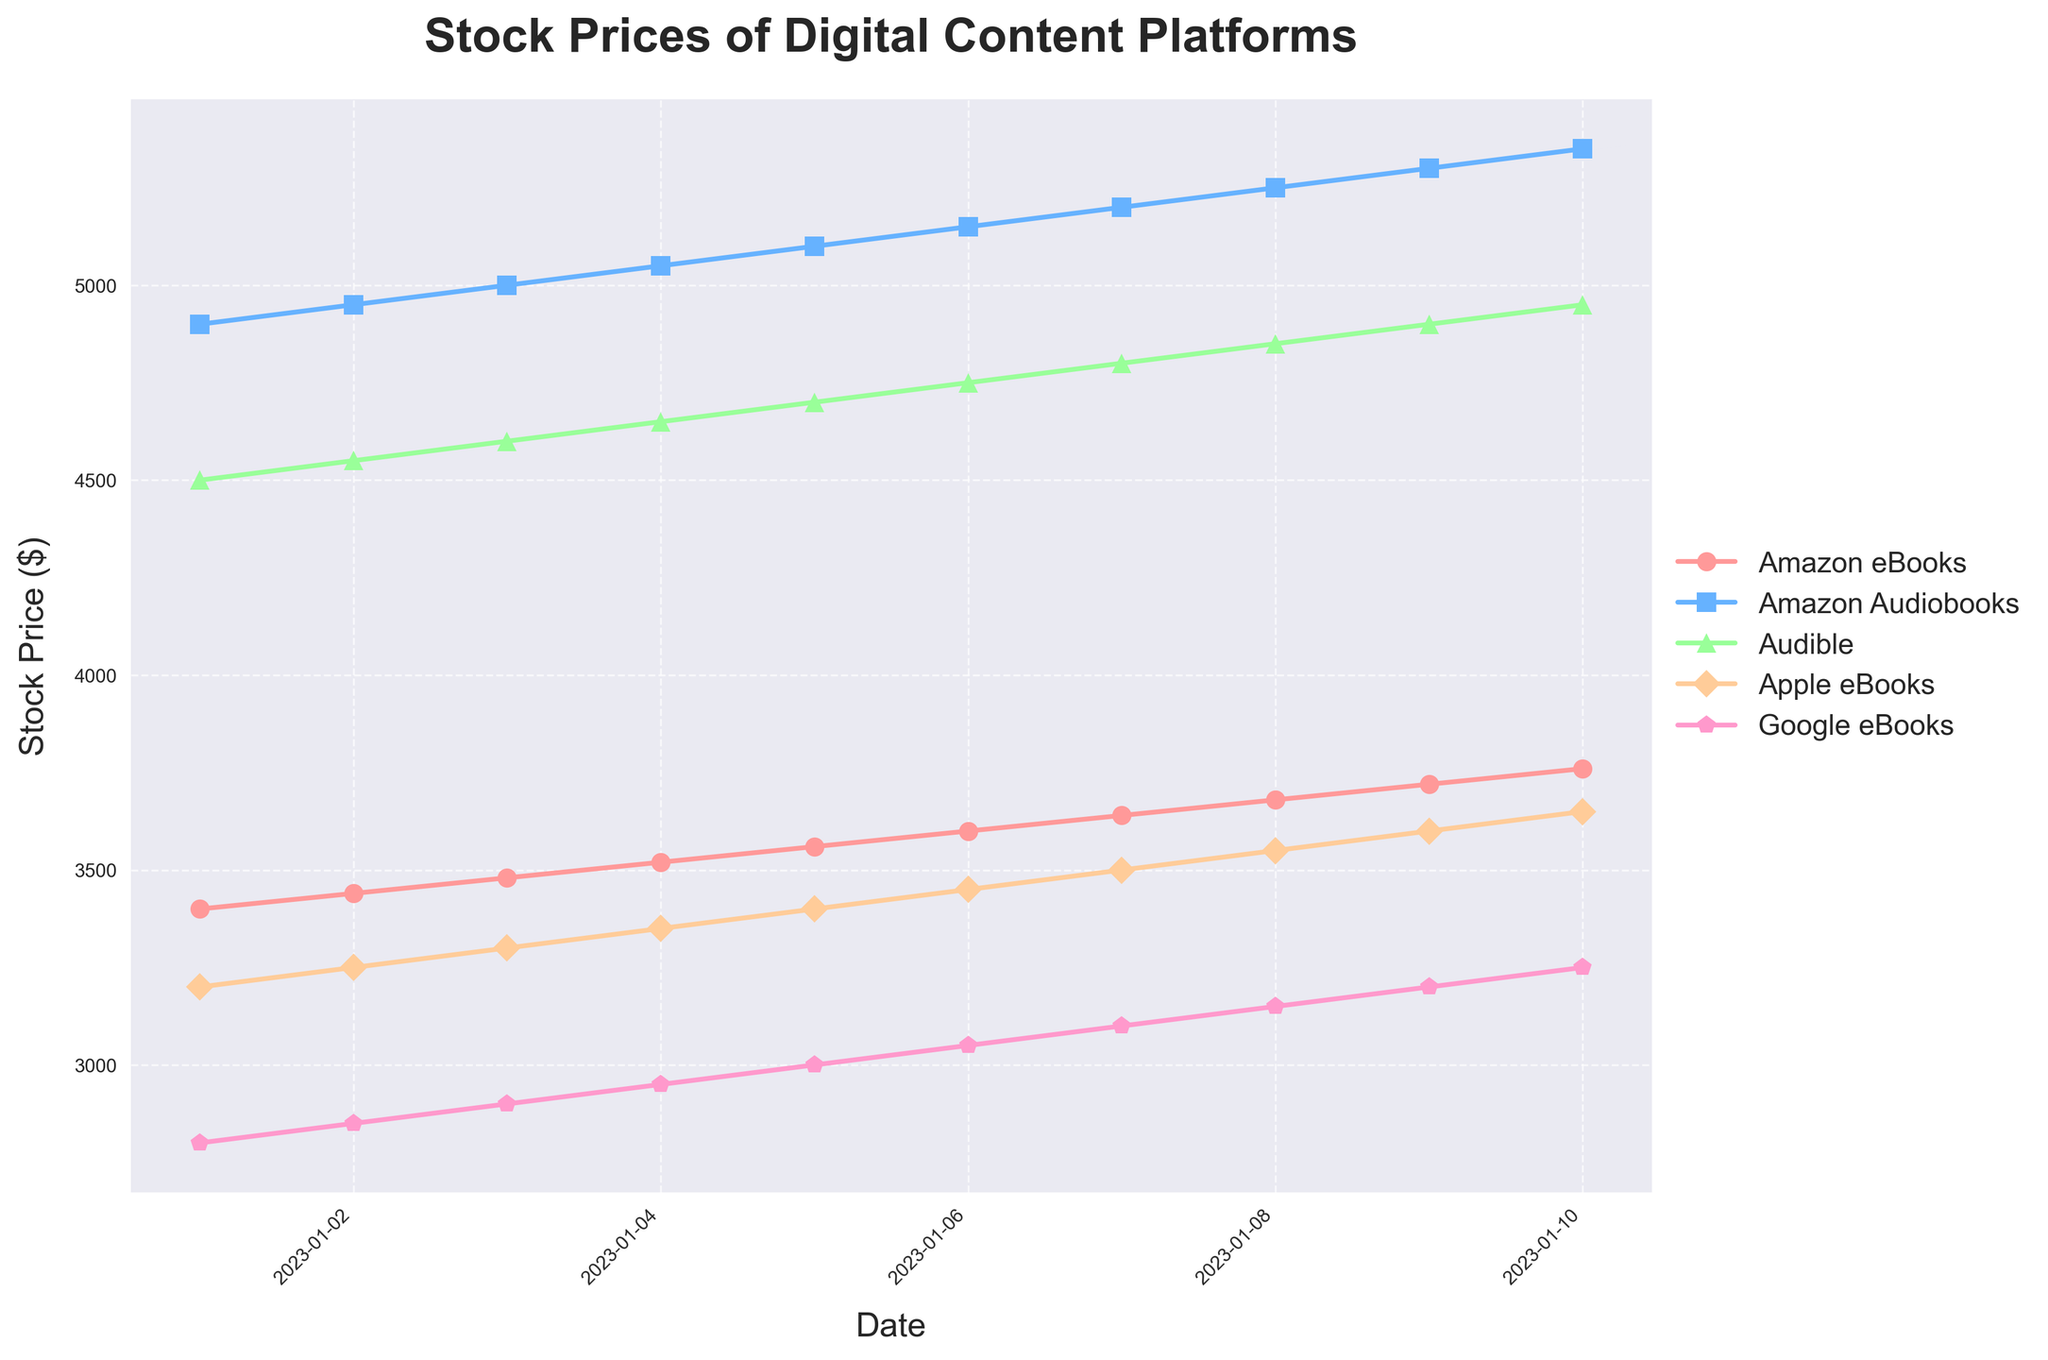What is the title of the plot? The title is the large, bold text at the top of the chart. It provides a concise description of what the chart is depicting.
Answer: Stock Prices of Digital Content Platforms How many companies' stock prices are plotted on the chart? By counting the number of distinct lines in the plot, each representing a different company.
Answer: 5 What is the color of the line representing Google eBooks? By looking at the legend on the right side of the plot and matching the company name to its corresponding line color.
Answer: Pink What is the stock price of Amazon Audiobooks on January 8, 2023? Locate the date January 8, 2023, on the x-axis and find the corresponding point on the line for Amazon Audiobooks.
Answer: 5250 Which company's stock price showed the highest increase from January 1 to January 10, 2023? Calculate the difference between the stock prices on January 1 and January 10 for each company and compare them. Amazon_eBooks: 3760-3400 = 360; Amazon_Audiobooks: 5350-4900 = 450; Audible: 4950-4500 = 450; Apple_eBooks: 3650-3200 = 450; Google_eBooks: 3250-2800 = 450. All companies except Amazon eBooks had the same highest increase.
Answer: Amazon Audiobooks, Audible, Apple eBooks, Google eBooks Which company's stock price was the highest on January 5, 2023? Locate January 5, 2023, on the x-axis and compare the heights of the points on that date for each company's line.
Answer: Amazon Audiobooks What is the average stock price of Apple eBooks over the dates shown in the plot? Sum the stock prices of Apple eBooks for each date and divide by the number of dates. (3200 + 3250 + 3300 + 3350 + 3400 + 3450 + 3500 + 3550 + 3600 + 3650) / 10 = 33250 / 10
Answer: 3325 How does the trend of Audible's stock price compare to that of Google eBooks over the time period? Observe the slopes and changes in the lines representing Audible and Google eBooks. Both lines show a consistent upward trend but verify the rate of increase. Audible starts at 4500 and goes to 4950 (up by 450). Google eBooks start at 2800 and end at 3250 (up by 450 as well).
Answer: Both increased by the same amount but started at different levels On January 6, 2023, which company had the lowest stock price? Locate January 6, 2023, on the x-axis and compare the points to see which is the lowest.
Answer: Google eBooks 